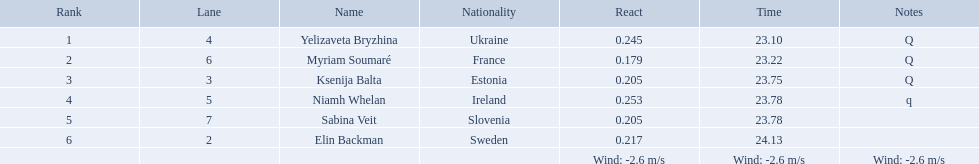What are all the titles? Yelizaveta Bryzhina, Myriam Soumaré, Ksenija Balta, Niamh Whelan, Sabina Veit, Elin Backman. What were their ending times? 23.10, 23.22, 23.75, 23.78, 23.78, 24.13. And which time was accomplished by ellen backman? 24.13. What position did elin backman complete the race in? 6. How much time did it take him to finish? 24.13. Which sportsman is from sweden? Elin Backman. What was their duration to complete the race? 24.13. In which spot did elin backman end the race? 6. How long was his completion time? 24.13. Parse the table in full. {'header': ['Rank', 'Lane', 'Name', 'Nationality', 'React', 'Time', 'Notes'], 'rows': [['1', '4', 'Yelizaveta Bryzhina', 'Ukraine', '0.245', '23.10', 'Q'], ['2', '6', 'Myriam Soumaré', 'France', '0.179', '23.22', 'Q'], ['3', '3', 'Ksenija Balta', 'Estonia', '0.205', '23.75', 'Q'], ['4', '5', 'Niamh Whelan', 'Ireland', '0.253', '23.78', 'q'], ['5', '7', 'Sabina Veit', 'Slovenia', '0.205', '23.78', ''], ['6', '2', 'Elin Backman', 'Sweden', '0.217', '24.13', ''], ['', '', '', '', 'Wind: -2.6\xa0m/s', 'Wind: -2.6\xa0m/s', 'Wind: -2.6\xa0m/s']]} 